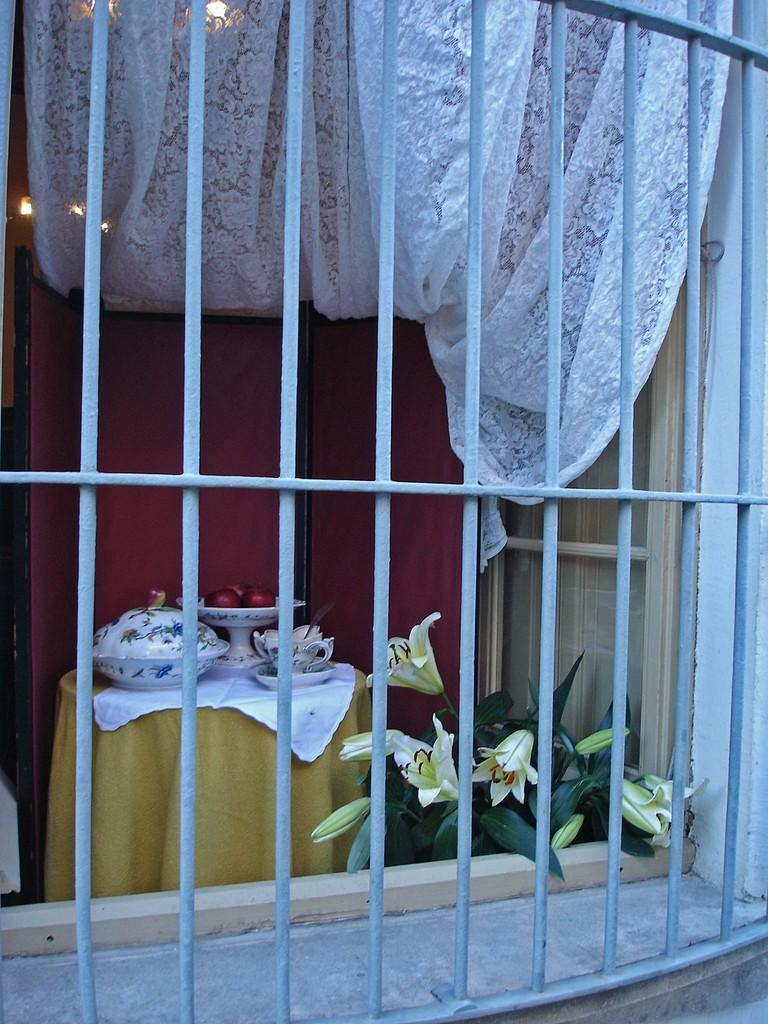Who is the main subject in the image? There is a girl in the image. What can be seen in the background of the image? Curtains are visible in the image. What type of vegetation is present in the image? There is a plant in the image. What is the primary piece of furniture in the image? A table is present in the image. What is hanging above the table? There is a bowl above the table. What items are on the table? There are things on the table, including fruits. What decorative elements are on the plant? Flowers are present on the plant. What type of grass can be seen growing on the edge of the table? There is no grass present on the edge of the table in the image. 